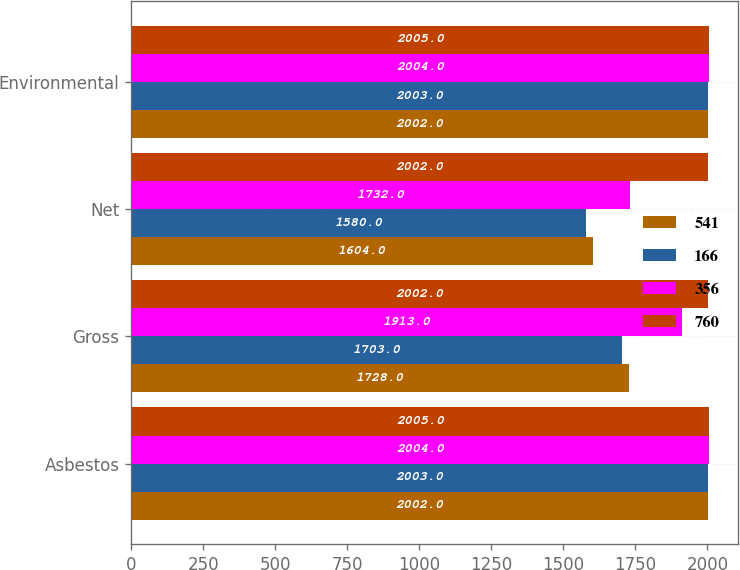<chart> <loc_0><loc_0><loc_500><loc_500><stacked_bar_chart><ecel><fcel>Asbestos<fcel>Gross<fcel>Net<fcel>Environmental<nl><fcel>541<fcel>2002<fcel>1728<fcel>1604<fcel>2002<nl><fcel>166<fcel>2003<fcel>1703<fcel>1580<fcel>2003<nl><fcel>356<fcel>2004<fcel>1913<fcel>1732<fcel>2004<nl><fcel>760<fcel>2005<fcel>2002<fcel>2002<fcel>2005<nl></chart> 